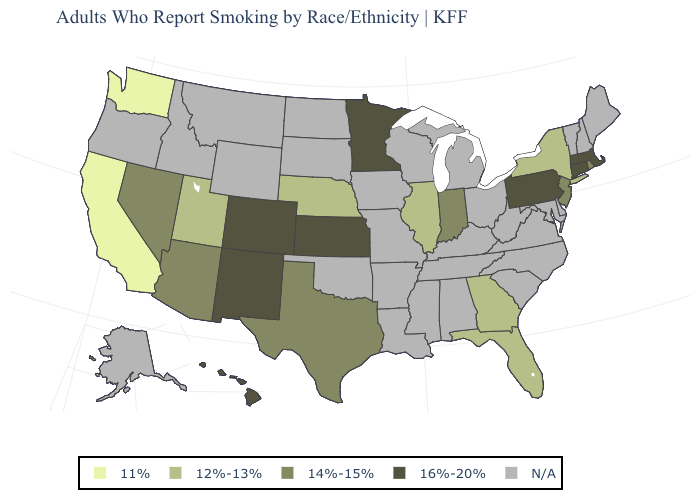What is the value of Illinois?
Keep it brief. 12%-13%. Which states hav the highest value in the MidWest?
Short answer required. Kansas, Minnesota. Does Minnesota have the lowest value in the USA?
Quick response, please. No. What is the value of Indiana?
Concise answer only. 14%-15%. What is the value of Mississippi?
Short answer required. N/A. What is the lowest value in the USA?
Write a very short answer. 11%. Is the legend a continuous bar?
Concise answer only. No. Does the first symbol in the legend represent the smallest category?
Keep it brief. Yes. Name the states that have a value in the range 12%-13%?
Quick response, please. Florida, Georgia, Illinois, Nebraska, New York, Utah. Name the states that have a value in the range 16%-20%?
Keep it brief. Colorado, Connecticut, Hawaii, Kansas, Massachusetts, Minnesota, New Mexico, Pennsylvania. Among the states that border Kansas , which have the lowest value?
Write a very short answer. Nebraska. Which states have the lowest value in the Northeast?
Keep it brief. New York. How many symbols are there in the legend?
Be succinct. 5. 